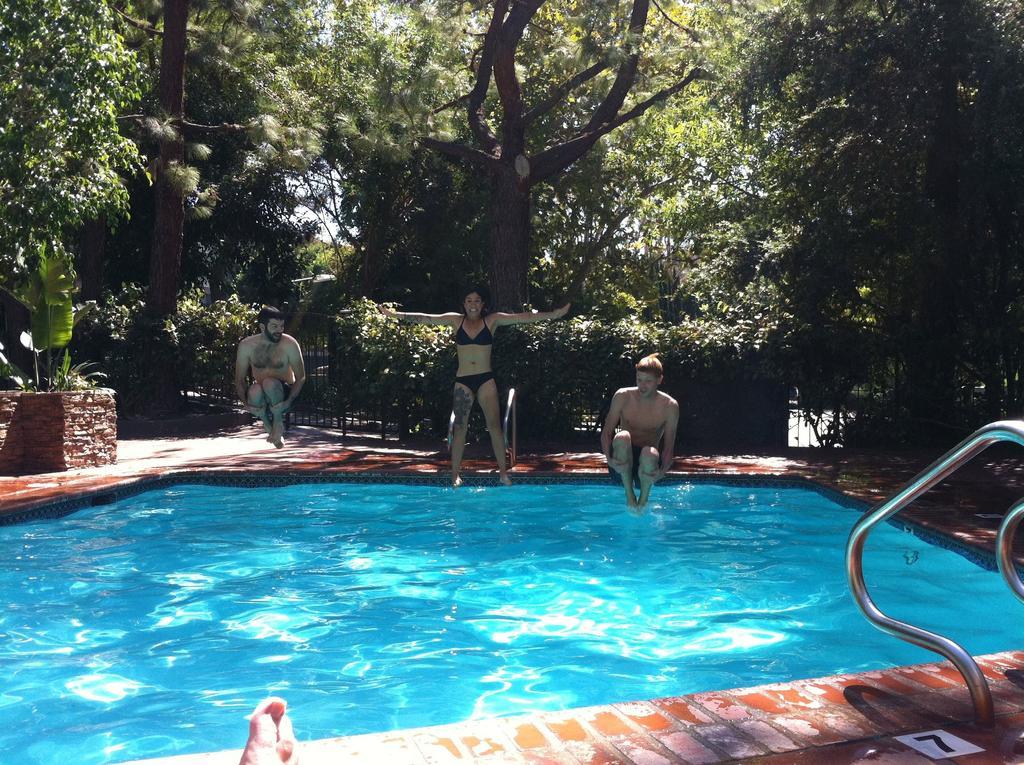Can you describe this image briefly? This picture shows a swimming pool. We see a man and a woman jumping into the water and another man seated and we see trees and another human leg and metal rods to climb up. 